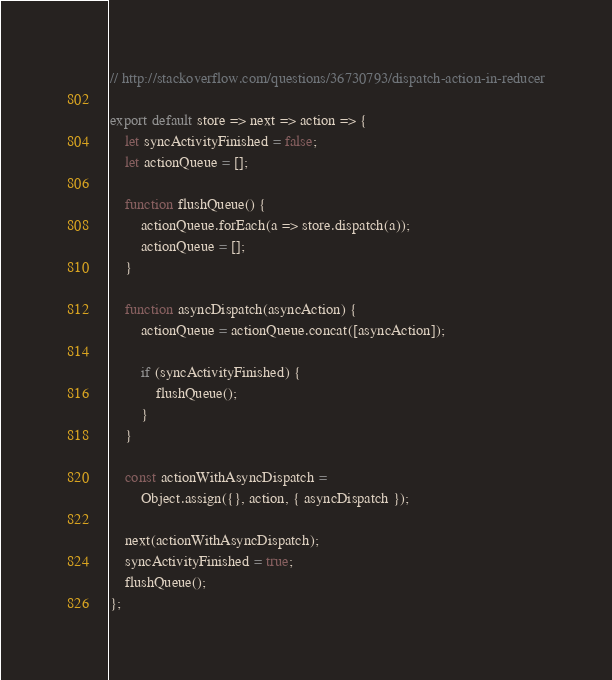<code> <loc_0><loc_0><loc_500><loc_500><_JavaScript_>// http://stackoverflow.com/questions/36730793/dispatch-action-in-reducer

export default store => next => action => {
	let syncActivityFinished = false;
	let actionQueue = [];

	function flushQueue() {
		actionQueue.forEach(a => store.dispatch(a));
		actionQueue = [];
	}

	function asyncDispatch(asyncAction) {
		actionQueue = actionQueue.concat([asyncAction]);

		if (syncActivityFinished) {
			flushQueue();
		}
	}

	const actionWithAsyncDispatch =
		Object.assign({}, action, { asyncDispatch });

	next(actionWithAsyncDispatch);
	syncActivityFinished = true;
	flushQueue();
};</code> 